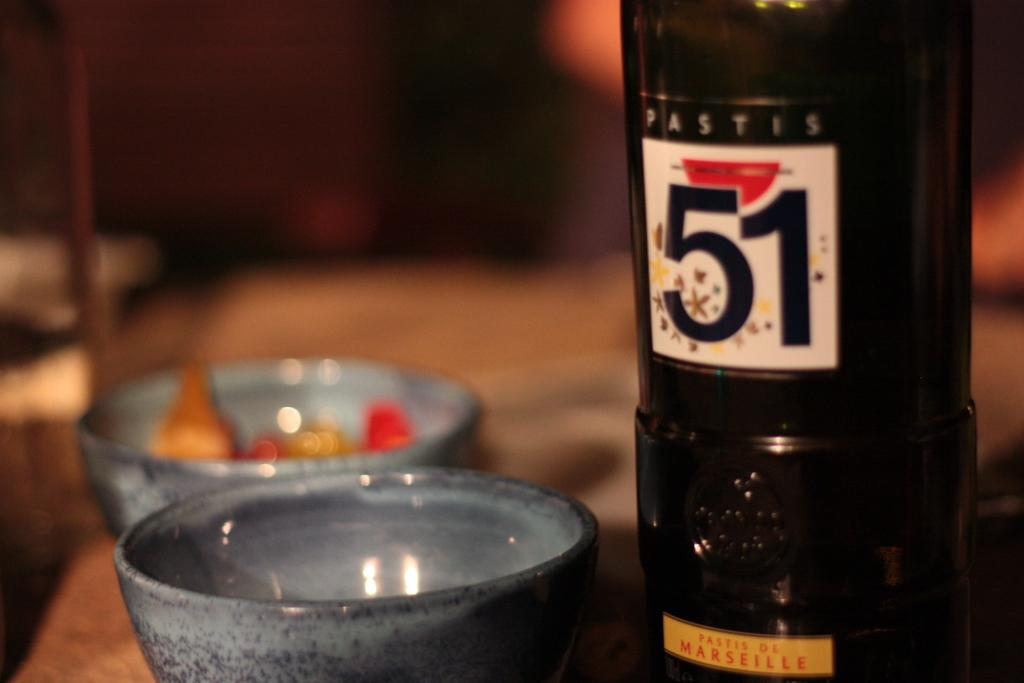<image>
Relay a brief, clear account of the picture shown. A black bottle of Pastis 51 from France next to a grey bowl. 